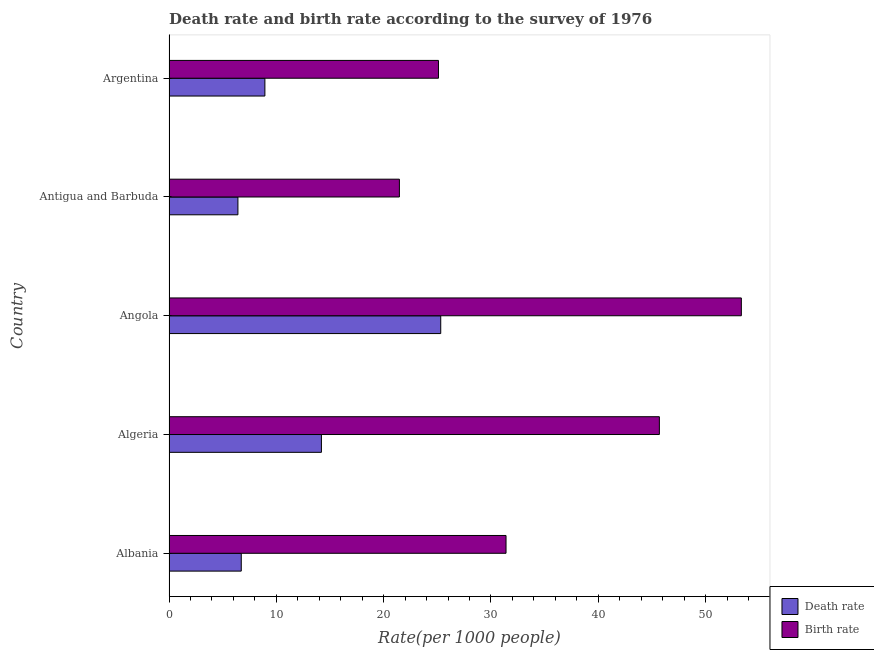How many different coloured bars are there?
Offer a very short reply. 2. How many groups of bars are there?
Offer a very short reply. 5. Are the number of bars per tick equal to the number of legend labels?
Ensure brevity in your answer.  Yes. Are the number of bars on each tick of the Y-axis equal?
Offer a very short reply. Yes. How many bars are there on the 1st tick from the bottom?
Provide a short and direct response. 2. What is the label of the 4th group of bars from the top?
Ensure brevity in your answer.  Algeria. What is the birth rate in Argentina?
Ensure brevity in your answer.  25.11. Across all countries, what is the maximum birth rate?
Provide a short and direct response. 53.33. Across all countries, what is the minimum birth rate?
Give a very brief answer. 21.47. In which country was the death rate maximum?
Make the answer very short. Angola. In which country was the death rate minimum?
Your answer should be compact. Antigua and Barbuda. What is the total death rate in the graph?
Provide a succinct answer. 61.61. What is the difference between the death rate in Antigua and Barbuda and that in Argentina?
Your answer should be very brief. -2.51. What is the difference between the death rate in Albania and the birth rate in Antigua and Barbuda?
Offer a very short reply. -14.73. What is the average birth rate per country?
Make the answer very short. 35.4. What is the difference between the death rate and birth rate in Antigua and Barbuda?
Keep it short and to the point. -15.04. In how many countries, is the death rate greater than 14 ?
Give a very brief answer. 2. What is the ratio of the birth rate in Algeria to that in Antigua and Barbuda?
Provide a short and direct response. 2.13. What is the difference between the highest and the second highest death rate?
Give a very brief answer. 11.12. What is the difference between the highest and the lowest death rate?
Offer a very short reply. 18.9. In how many countries, is the death rate greater than the average death rate taken over all countries?
Offer a very short reply. 2. Is the sum of the death rate in Albania and Angola greater than the maximum birth rate across all countries?
Your answer should be compact. No. What does the 2nd bar from the top in Angola represents?
Offer a terse response. Death rate. What does the 2nd bar from the bottom in Argentina represents?
Give a very brief answer. Birth rate. Are the values on the major ticks of X-axis written in scientific E-notation?
Offer a very short reply. No. Where does the legend appear in the graph?
Your answer should be compact. Bottom right. How many legend labels are there?
Your response must be concise. 2. How are the legend labels stacked?
Make the answer very short. Vertical. What is the title of the graph?
Offer a terse response. Death rate and birth rate according to the survey of 1976. What is the label or title of the X-axis?
Keep it short and to the point. Rate(per 1000 people). What is the Rate(per 1000 people) of Death rate in Albania?
Offer a very short reply. 6.73. What is the Rate(per 1000 people) of Birth rate in Albania?
Your answer should be very brief. 31.4. What is the Rate(per 1000 people) in Death rate in Algeria?
Keep it short and to the point. 14.2. What is the Rate(per 1000 people) in Birth rate in Algeria?
Ensure brevity in your answer.  45.69. What is the Rate(per 1000 people) in Death rate in Angola?
Provide a short and direct response. 25.32. What is the Rate(per 1000 people) in Birth rate in Angola?
Your response must be concise. 53.33. What is the Rate(per 1000 people) of Death rate in Antigua and Barbuda?
Provide a succinct answer. 6.42. What is the Rate(per 1000 people) in Birth rate in Antigua and Barbuda?
Keep it short and to the point. 21.47. What is the Rate(per 1000 people) of Death rate in Argentina?
Your answer should be compact. 8.93. What is the Rate(per 1000 people) in Birth rate in Argentina?
Your answer should be compact. 25.11. Across all countries, what is the maximum Rate(per 1000 people) of Death rate?
Your answer should be compact. 25.32. Across all countries, what is the maximum Rate(per 1000 people) of Birth rate?
Give a very brief answer. 53.33. Across all countries, what is the minimum Rate(per 1000 people) in Death rate?
Your answer should be compact. 6.42. Across all countries, what is the minimum Rate(per 1000 people) in Birth rate?
Provide a short and direct response. 21.47. What is the total Rate(per 1000 people) in Death rate in the graph?
Provide a short and direct response. 61.61. What is the total Rate(per 1000 people) in Birth rate in the graph?
Your answer should be compact. 176.99. What is the difference between the Rate(per 1000 people) in Death rate in Albania and that in Algeria?
Provide a succinct answer. -7.47. What is the difference between the Rate(per 1000 people) of Birth rate in Albania and that in Algeria?
Your response must be concise. -14.29. What is the difference between the Rate(per 1000 people) in Death rate in Albania and that in Angola?
Your response must be concise. -18.59. What is the difference between the Rate(per 1000 people) of Birth rate in Albania and that in Angola?
Offer a very short reply. -21.93. What is the difference between the Rate(per 1000 people) of Death rate in Albania and that in Antigua and Barbuda?
Provide a succinct answer. 0.31. What is the difference between the Rate(per 1000 people) of Birth rate in Albania and that in Antigua and Barbuda?
Provide a short and direct response. 9.94. What is the difference between the Rate(per 1000 people) of Death rate in Albania and that in Argentina?
Provide a succinct answer. -2.2. What is the difference between the Rate(per 1000 people) of Birth rate in Albania and that in Argentina?
Your response must be concise. 6.29. What is the difference between the Rate(per 1000 people) of Death rate in Algeria and that in Angola?
Your answer should be very brief. -11.12. What is the difference between the Rate(per 1000 people) of Birth rate in Algeria and that in Angola?
Offer a very short reply. -7.64. What is the difference between the Rate(per 1000 people) of Death rate in Algeria and that in Antigua and Barbuda?
Offer a very short reply. 7.78. What is the difference between the Rate(per 1000 people) in Birth rate in Algeria and that in Antigua and Barbuda?
Offer a very short reply. 24.22. What is the difference between the Rate(per 1000 people) of Death rate in Algeria and that in Argentina?
Offer a very short reply. 5.27. What is the difference between the Rate(per 1000 people) of Birth rate in Algeria and that in Argentina?
Keep it short and to the point. 20.58. What is the difference between the Rate(per 1000 people) in Death rate in Angola and that in Antigua and Barbuda?
Provide a short and direct response. 18.9. What is the difference between the Rate(per 1000 people) in Birth rate in Angola and that in Antigua and Barbuda?
Your answer should be compact. 31.86. What is the difference between the Rate(per 1000 people) of Death rate in Angola and that in Argentina?
Provide a short and direct response. 16.39. What is the difference between the Rate(per 1000 people) in Birth rate in Angola and that in Argentina?
Make the answer very short. 28.22. What is the difference between the Rate(per 1000 people) in Death rate in Antigua and Barbuda and that in Argentina?
Provide a succinct answer. -2.51. What is the difference between the Rate(per 1000 people) in Birth rate in Antigua and Barbuda and that in Argentina?
Provide a succinct answer. -3.64. What is the difference between the Rate(per 1000 people) in Death rate in Albania and the Rate(per 1000 people) in Birth rate in Algeria?
Make the answer very short. -38.96. What is the difference between the Rate(per 1000 people) of Death rate in Albania and the Rate(per 1000 people) of Birth rate in Angola?
Keep it short and to the point. -46.59. What is the difference between the Rate(per 1000 people) in Death rate in Albania and the Rate(per 1000 people) in Birth rate in Antigua and Barbuda?
Offer a terse response. -14.73. What is the difference between the Rate(per 1000 people) in Death rate in Albania and the Rate(per 1000 people) in Birth rate in Argentina?
Give a very brief answer. -18.37. What is the difference between the Rate(per 1000 people) in Death rate in Algeria and the Rate(per 1000 people) in Birth rate in Angola?
Offer a terse response. -39.12. What is the difference between the Rate(per 1000 people) of Death rate in Algeria and the Rate(per 1000 people) of Birth rate in Antigua and Barbuda?
Provide a succinct answer. -7.26. What is the difference between the Rate(per 1000 people) in Death rate in Algeria and the Rate(per 1000 people) in Birth rate in Argentina?
Provide a succinct answer. -10.9. What is the difference between the Rate(per 1000 people) of Death rate in Angola and the Rate(per 1000 people) of Birth rate in Antigua and Barbuda?
Your answer should be compact. 3.85. What is the difference between the Rate(per 1000 people) in Death rate in Angola and the Rate(per 1000 people) in Birth rate in Argentina?
Provide a succinct answer. 0.21. What is the difference between the Rate(per 1000 people) of Death rate in Antigua and Barbuda and the Rate(per 1000 people) of Birth rate in Argentina?
Give a very brief answer. -18.68. What is the average Rate(per 1000 people) of Death rate per country?
Keep it short and to the point. 12.32. What is the average Rate(per 1000 people) of Birth rate per country?
Offer a terse response. 35.4. What is the difference between the Rate(per 1000 people) of Death rate and Rate(per 1000 people) of Birth rate in Albania?
Ensure brevity in your answer.  -24.67. What is the difference between the Rate(per 1000 people) in Death rate and Rate(per 1000 people) in Birth rate in Algeria?
Give a very brief answer. -31.49. What is the difference between the Rate(per 1000 people) of Death rate and Rate(per 1000 people) of Birth rate in Angola?
Give a very brief answer. -28.01. What is the difference between the Rate(per 1000 people) of Death rate and Rate(per 1000 people) of Birth rate in Antigua and Barbuda?
Make the answer very short. -15.04. What is the difference between the Rate(per 1000 people) in Death rate and Rate(per 1000 people) in Birth rate in Argentina?
Your answer should be compact. -16.17. What is the ratio of the Rate(per 1000 people) in Death rate in Albania to that in Algeria?
Keep it short and to the point. 0.47. What is the ratio of the Rate(per 1000 people) in Birth rate in Albania to that in Algeria?
Your answer should be very brief. 0.69. What is the ratio of the Rate(per 1000 people) of Death rate in Albania to that in Angola?
Your answer should be compact. 0.27. What is the ratio of the Rate(per 1000 people) of Birth rate in Albania to that in Angola?
Provide a succinct answer. 0.59. What is the ratio of the Rate(per 1000 people) of Death rate in Albania to that in Antigua and Barbuda?
Your answer should be compact. 1.05. What is the ratio of the Rate(per 1000 people) of Birth rate in Albania to that in Antigua and Barbuda?
Offer a very short reply. 1.46. What is the ratio of the Rate(per 1000 people) of Death rate in Albania to that in Argentina?
Offer a very short reply. 0.75. What is the ratio of the Rate(per 1000 people) of Birth rate in Albania to that in Argentina?
Provide a succinct answer. 1.25. What is the ratio of the Rate(per 1000 people) in Death rate in Algeria to that in Angola?
Make the answer very short. 0.56. What is the ratio of the Rate(per 1000 people) of Birth rate in Algeria to that in Angola?
Provide a succinct answer. 0.86. What is the ratio of the Rate(per 1000 people) of Death rate in Algeria to that in Antigua and Barbuda?
Offer a terse response. 2.21. What is the ratio of the Rate(per 1000 people) in Birth rate in Algeria to that in Antigua and Barbuda?
Provide a succinct answer. 2.13. What is the ratio of the Rate(per 1000 people) of Death rate in Algeria to that in Argentina?
Provide a short and direct response. 1.59. What is the ratio of the Rate(per 1000 people) in Birth rate in Algeria to that in Argentina?
Keep it short and to the point. 1.82. What is the ratio of the Rate(per 1000 people) of Death rate in Angola to that in Antigua and Barbuda?
Provide a short and direct response. 3.94. What is the ratio of the Rate(per 1000 people) of Birth rate in Angola to that in Antigua and Barbuda?
Provide a short and direct response. 2.48. What is the ratio of the Rate(per 1000 people) of Death rate in Angola to that in Argentina?
Offer a terse response. 2.83. What is the ratio of the Rate(per 1000 people) in Birth rate in Angola to that in Argentina?
Keep it short and to the point. 2.12. What is the ratio of the Rate(per 1000 people) of Death rate in Antigua and Barbuda to that in Argentina?
Ensure brevity in your answer.  0.72. What is the ratio of the Rate(per 1000 people) of Birth rate in Antigua and Barbuda to that in Argentina?
Your answer should be very brief. 0.85. What is the difference between the highest and the second highest Rate(per 1000 people) in Death rate?
Your answer should be compact. 11.12. What is the difference between the highest and the second highest Rate(per 1000 people) in Birth rate?
Offer a very short reply. 7.64. What is the difference between the highest and the lowest Rate(per 1000 people) in Death rate?
Provide a short and direct response. 18.9. What is the difference between the highest and the lowest Rate(per 1000 people) of Birth rate?
Offer a very short reply. 31.86. 